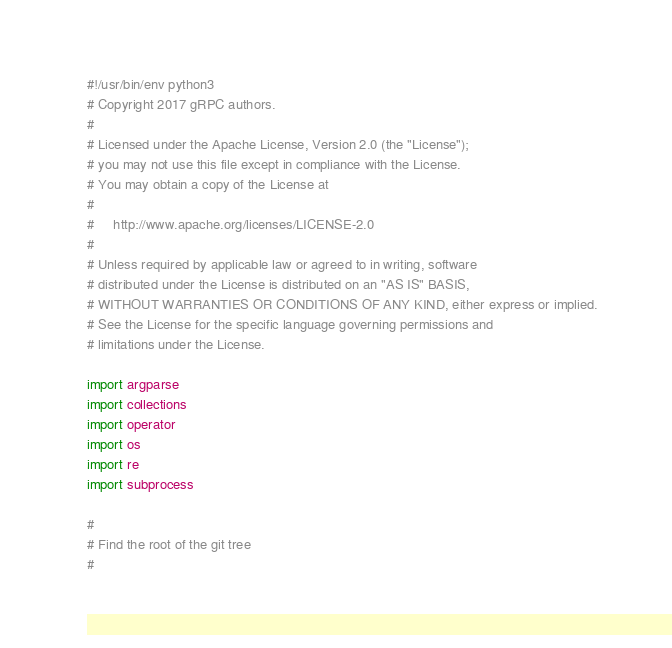Convert code to text. <code><loc_0><loc_0><loc_500><loc_500><_Python_>#!/usr/bin/env python3
# Copyright 2017 gRPC authors.
#
# Licensed under the Apache License, Version 2.0 (the "License");
# you may not use this file except in compliance with the License.
# You may obtain a copy of the License at
#
#     http://www.apache.org/licenses/LICENSE-2.0
#
# Unless required by applicable law or agreed to in writing, software
# distributed under the License is distributed on an "AS IS" BASIS,
# WITHOUT WARRANTIES OR CONDITIONS OF ANY KIND, either express or implied.
# See the License for the specific language governing permissions and
# limitations under the License.

import argparse
import collections
import operator
import os
import re
import subprocess

#
# Find the root of the git tree
#
</code> 